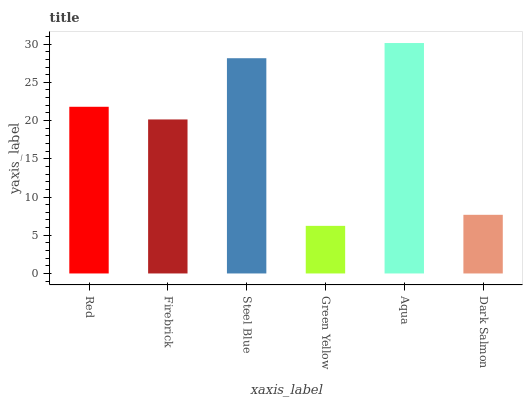Is Green Yellow the minimum?
Answer yes or no. Yes. Is Aqua the maximum?
Answer yes or no. Yes. Is Firebrick the minimum?
Answer yes or no. No. Is Firebrick the maximum?
Answer yes or no. No. Is Red greater than Firebrick?
Answer yes or no. Yes. Is Firebrick less than Red?
Answer yes or no. Yes. Is Firebrick greater than Red?
Answer yes or no. No. Is Red less than Firebrick?
Answer yes or no. No. Is Red the high median?
Answer yes or no. Yes. Is Firebrick the low median?
Answer yes or no. Yes. Is Aqua the high median?
Answer yes or no. No. Is Aqua the low median?
Answer yes or no. No. 